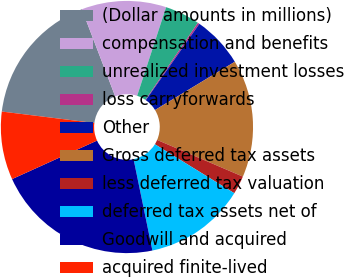<chart> <loc_0><loc_0><loc_500><loc_500><pie_chart><fcel>(Dollar amounts in millions)<fcel>compensation and benefits<fcel>unrealized investment losses<fcel>loss carryforwards<fcel>Other<fcel>Gross deferred tax assets<fcel>less deferred tax valuation<fcel>deferred tax assets net of<fcel>Goodwill and acquired<fcel>acquired finite-lived<nl><fcel>17.22%<fcel>10.85%<fcel>4.48%<fcel>0.23%<fcel>6.6%<fcel>15.09%<fcel>2.36%<fcel>12.97%<fcel>21.46%<fcel>8.73%<nl></chart> 